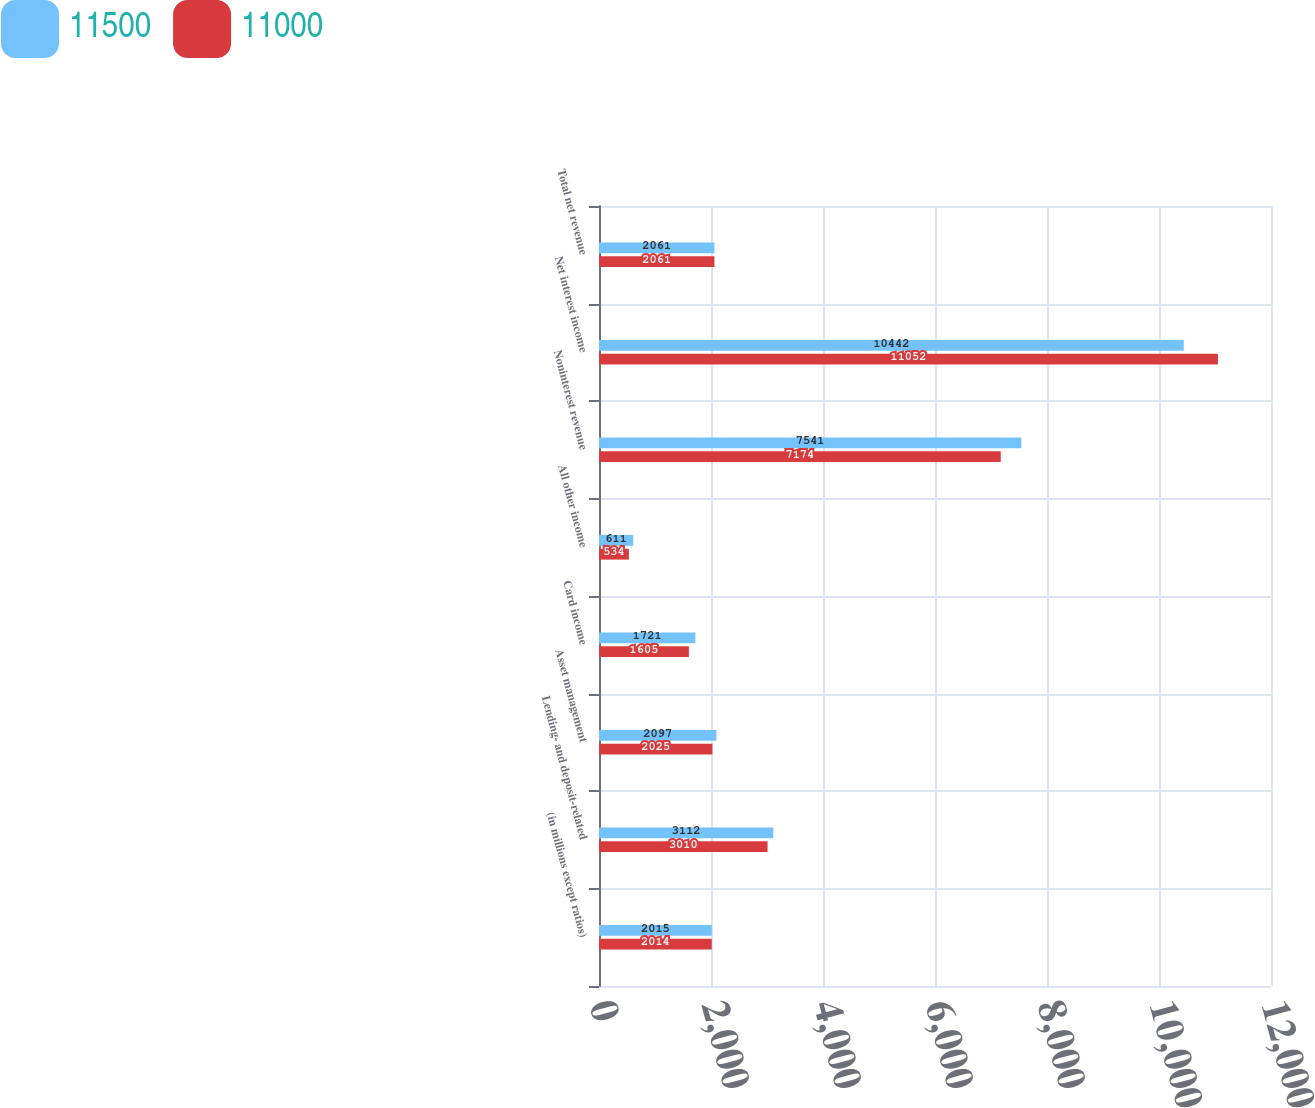Convert chart. <chart><loc_0><loc_0><loc_500><loc_500><stacked_bar_chart><ecel><fcel>(in millions except ratios)<fcel>Lending- and deposit-related<fcel>Asset management<fcel>Card income<fcel>All other income<fcel>Noninterest revenue<fcel>Net interest income<fcel>Total net revenue<nl><fcel>11500<fcel>2015<fcel>3112<fcel>2097<fcel>1721<fcel>611<fcel>7541<fcel>10442<fcel>2061<nl><fcel>11000<fcel>2014<fcel>3010<fcel>2025<fcel>1605<fcel>534<fcel>7174<fcel>11052<fcel>2061<nl></chart> 